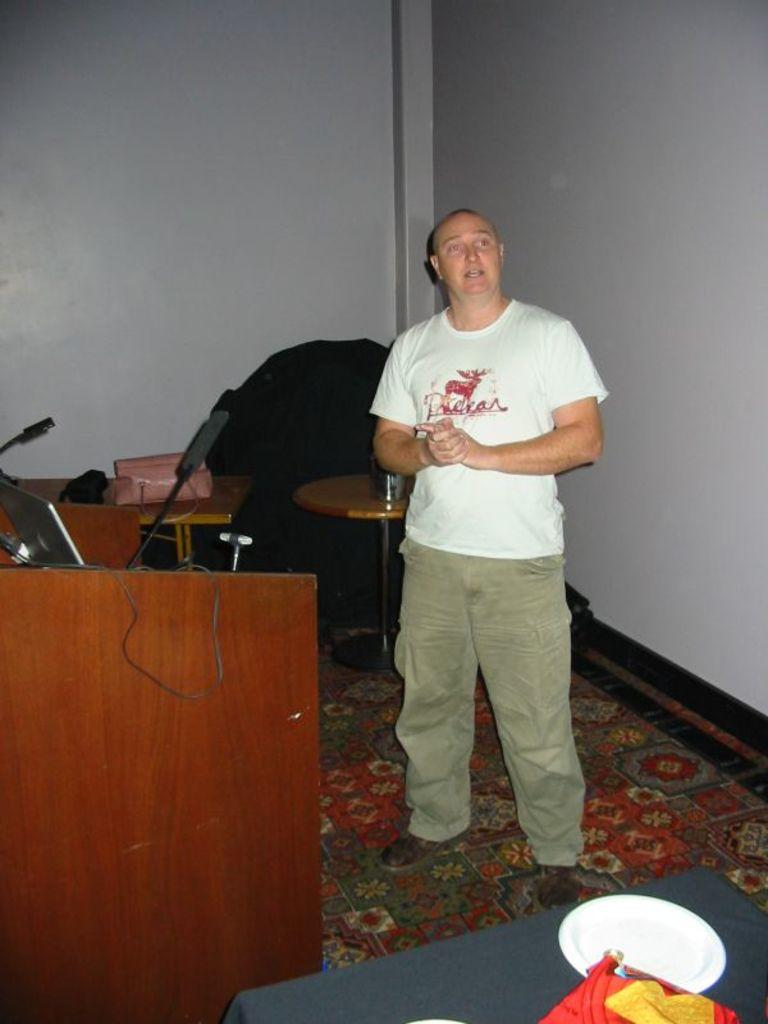What is the color of the wall in the image? The wall in the image is white. What type of furniture is present in the image? There are tables in the image. What is placed on the table in the image? There is a plate in the image. Who is present in the image? There is a man in the image. What is the man wearing in the image? The man is wearing a white color t-shirt. What is the man doing in the image? The man is standing in the image. Can you tell me the condition of the bike in the image? There is no bike present in the image. Is there a window visible in the image? The provided facts do not mention a window, so we cannot determine if there is one in the image. 